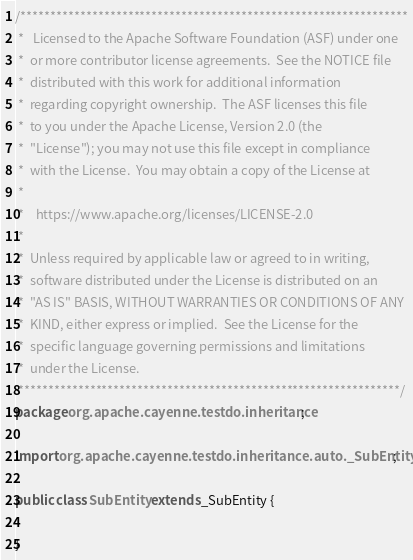Convert code to text. <code><loc_0><loc_0><loc_500><loc_500><_Java_>/*****************************************************************
 *   Licensed to the Apache Software Foundation (ASF) under one
 *  or more contributor license agreements.  See the NOTICE file
 *  distributed with this work for additional information
 *  regarding copyright ownership.  The ASF licenses this file
 *  to you under the Apache License, Version 2.0 (the
 *  "License"); you may not use this file except in compliance
 *  with the License.  You may obtain a copy of the License at
 *
 *    https://www.apache.org/licenses/LICENSE-2.0
 *
 *  Unless required by applicable law or agreed to in writing,
 *  software distributed under the License is distributed on an
 *  "AS IS" BASIS, WITHOUT WARRANTIES OR CONDITIONS OF ANY
 *  KIND, either express or implied.  See the License for the
 *  specific language governing permissions and limitations
 *  under the License.
 ****************************************************************/
package org.apache.cayenne.testdo.inheritance;

import org.apache.cayenne.testdo.inheritance.auto._SubEntity;

public class SubEntity extends _SubEntity {

}
</code> 